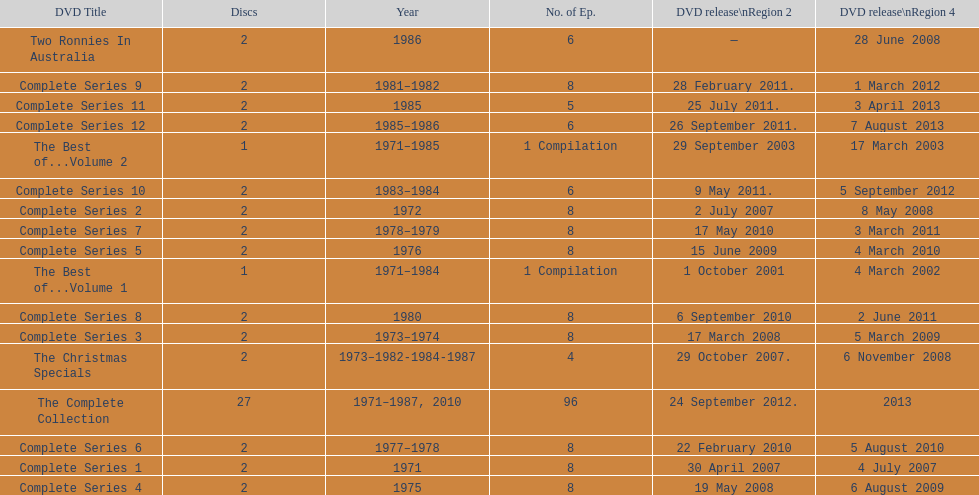True or false. the television show "the two ronnies" featured more than 10 episodes in a season. False. 